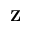<formula> <loc_0><loc_0><loc_500><loc_500>\mathbf Z</formula> 